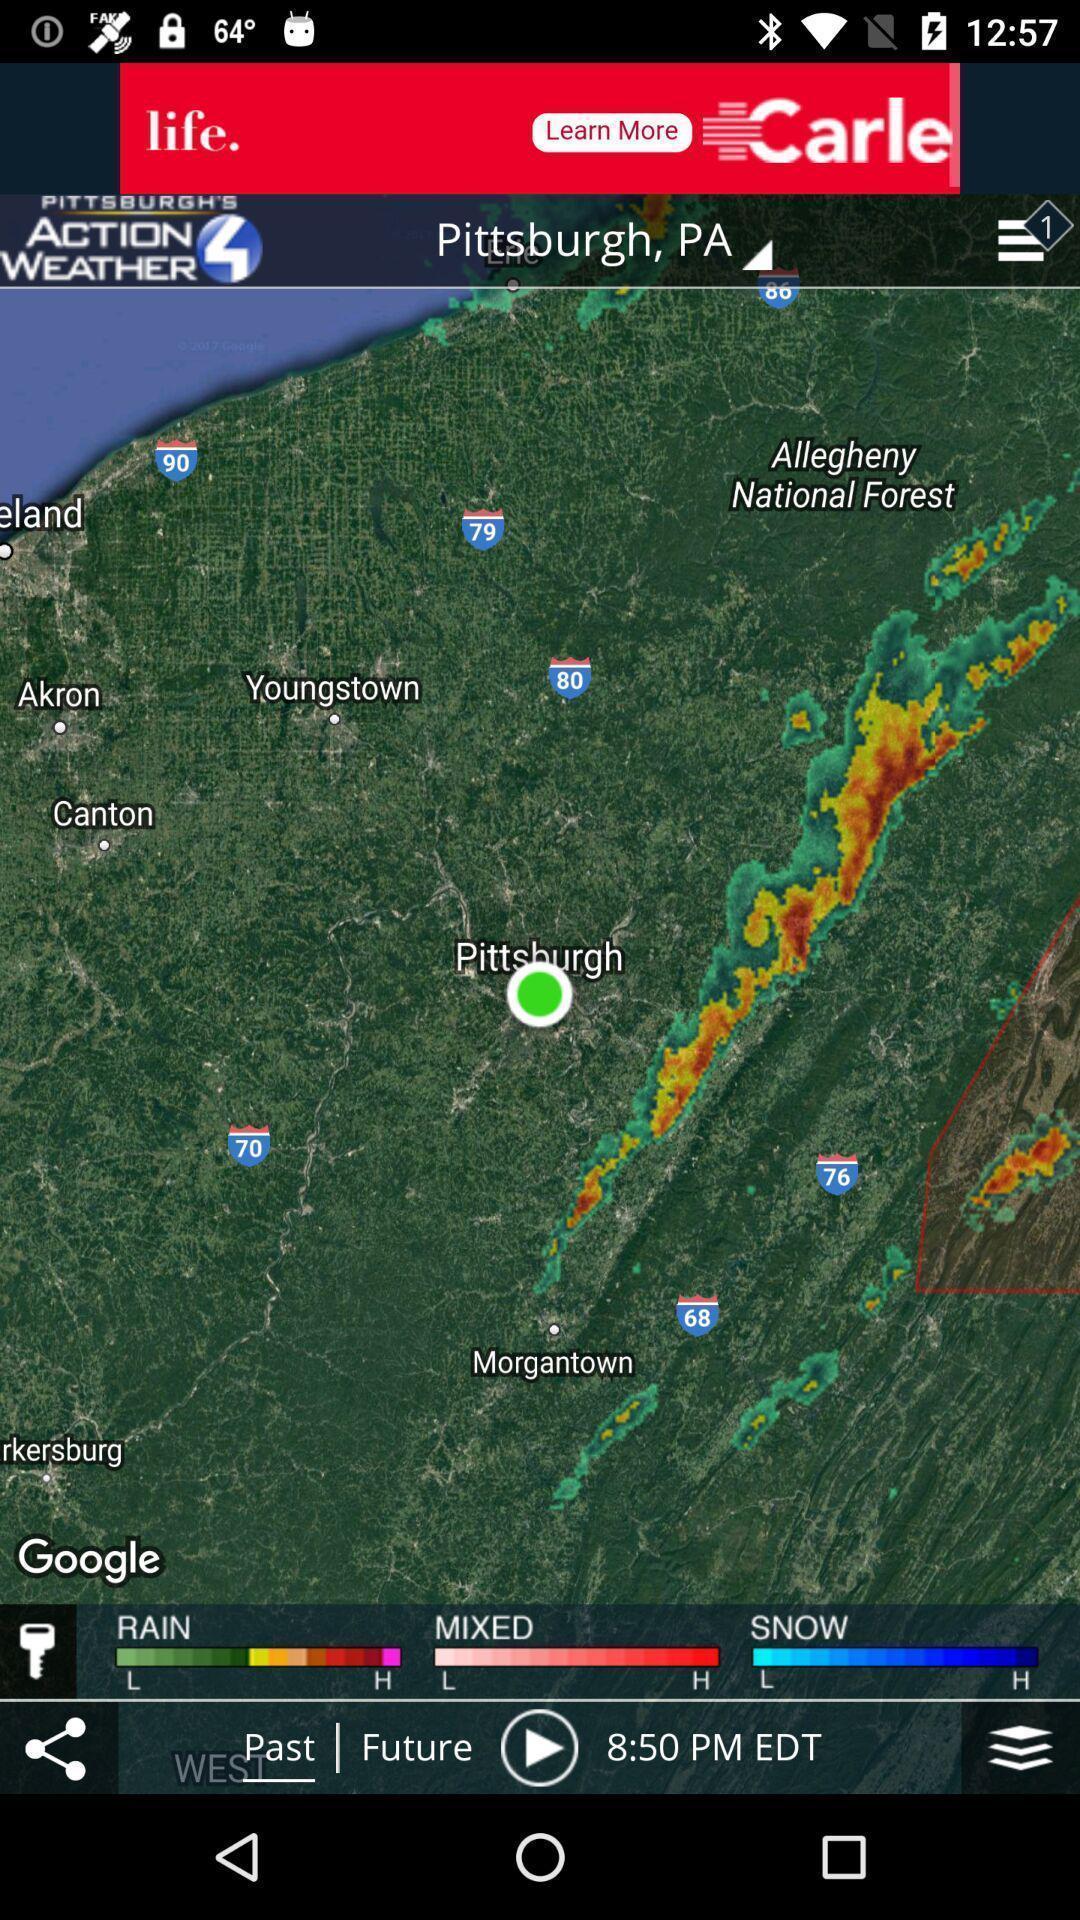Summarize the main components in this picture. Page showing different options on a map app. 